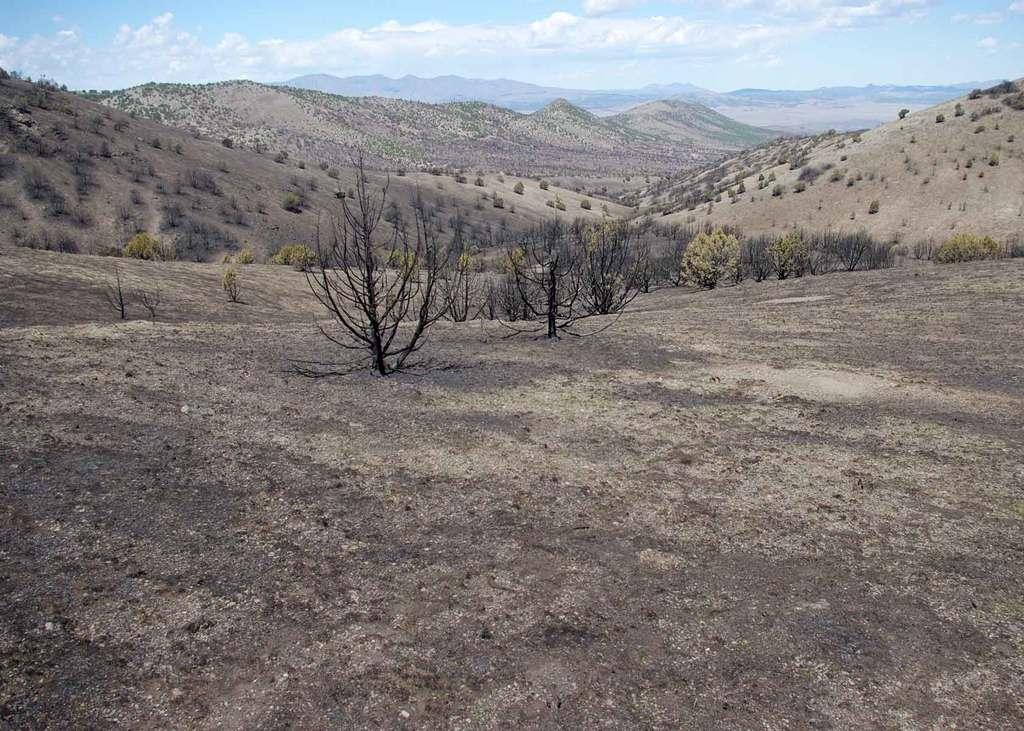What type of vegetation can be seen in the image? There is a group of trees and plants on the ground in the image. Are there any other types of vegetation visible in the image? Yes, there are shrubs on the hills in the background of the image. What can be seen in the sky in the image? The sky is visible in the image, and it appears cloudy. What is the afterthought of the battle that took place in the image? There is no battle present in the image, so there is no afterthought to discuss. What need is being addressed by the presence of the plants in the image? The image does not indicate any specific need being addressed by the presence of the plants; they are simply part of the natural landscape. 